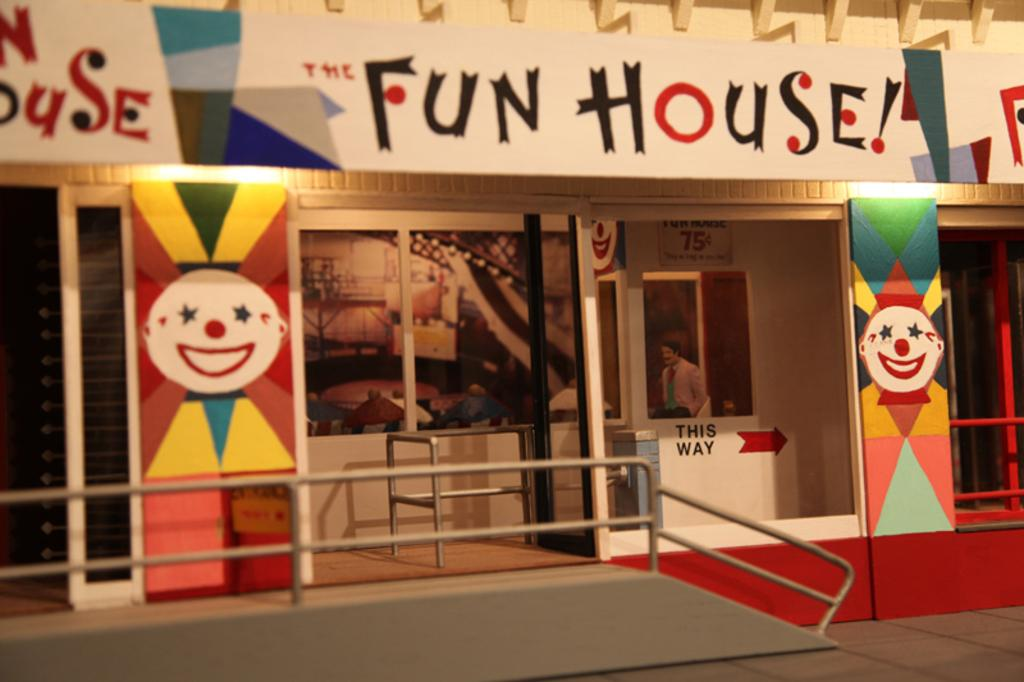<image>
Offer a succinct explanation of the picture presented. A building with clowns on it says The Fun House. 